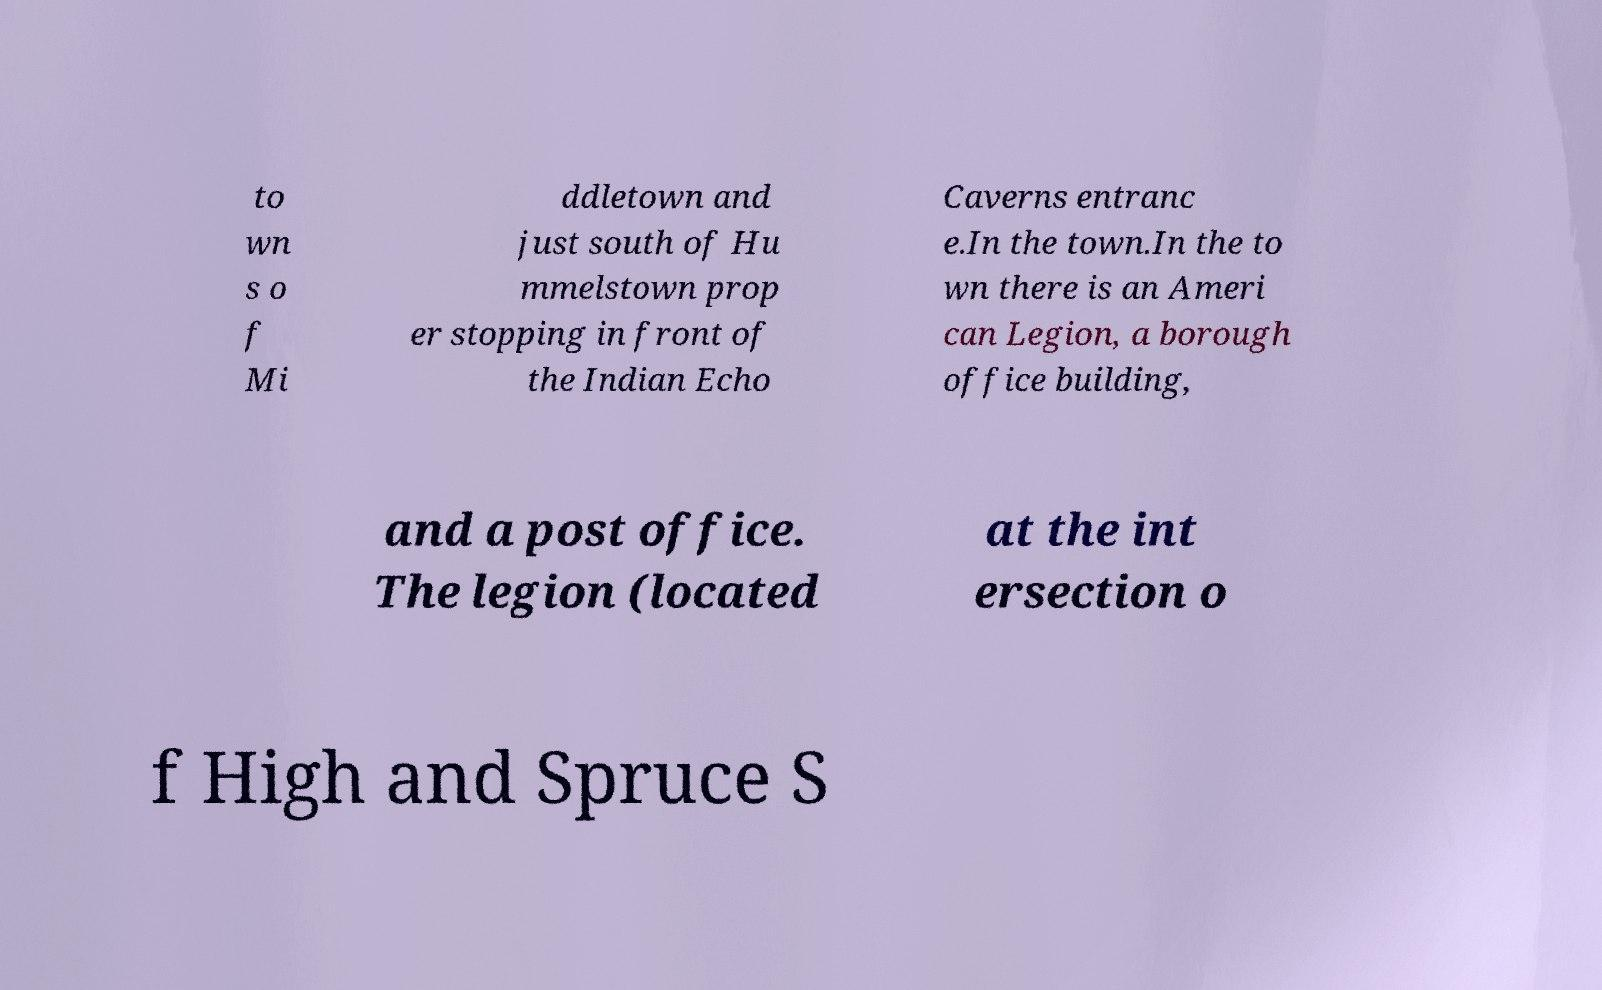Can you accurately transcribe the text from the provided image for me? to wn s o f Mi ddletown and just south of Hu mmelstown prop er stopping in front of the Indian Echo Caverns entranc e.In the town.In the to wn there is an Ameri can Legion, a borough office building, and a post office. The legion (located at the int ersection o f High and Spruce S 